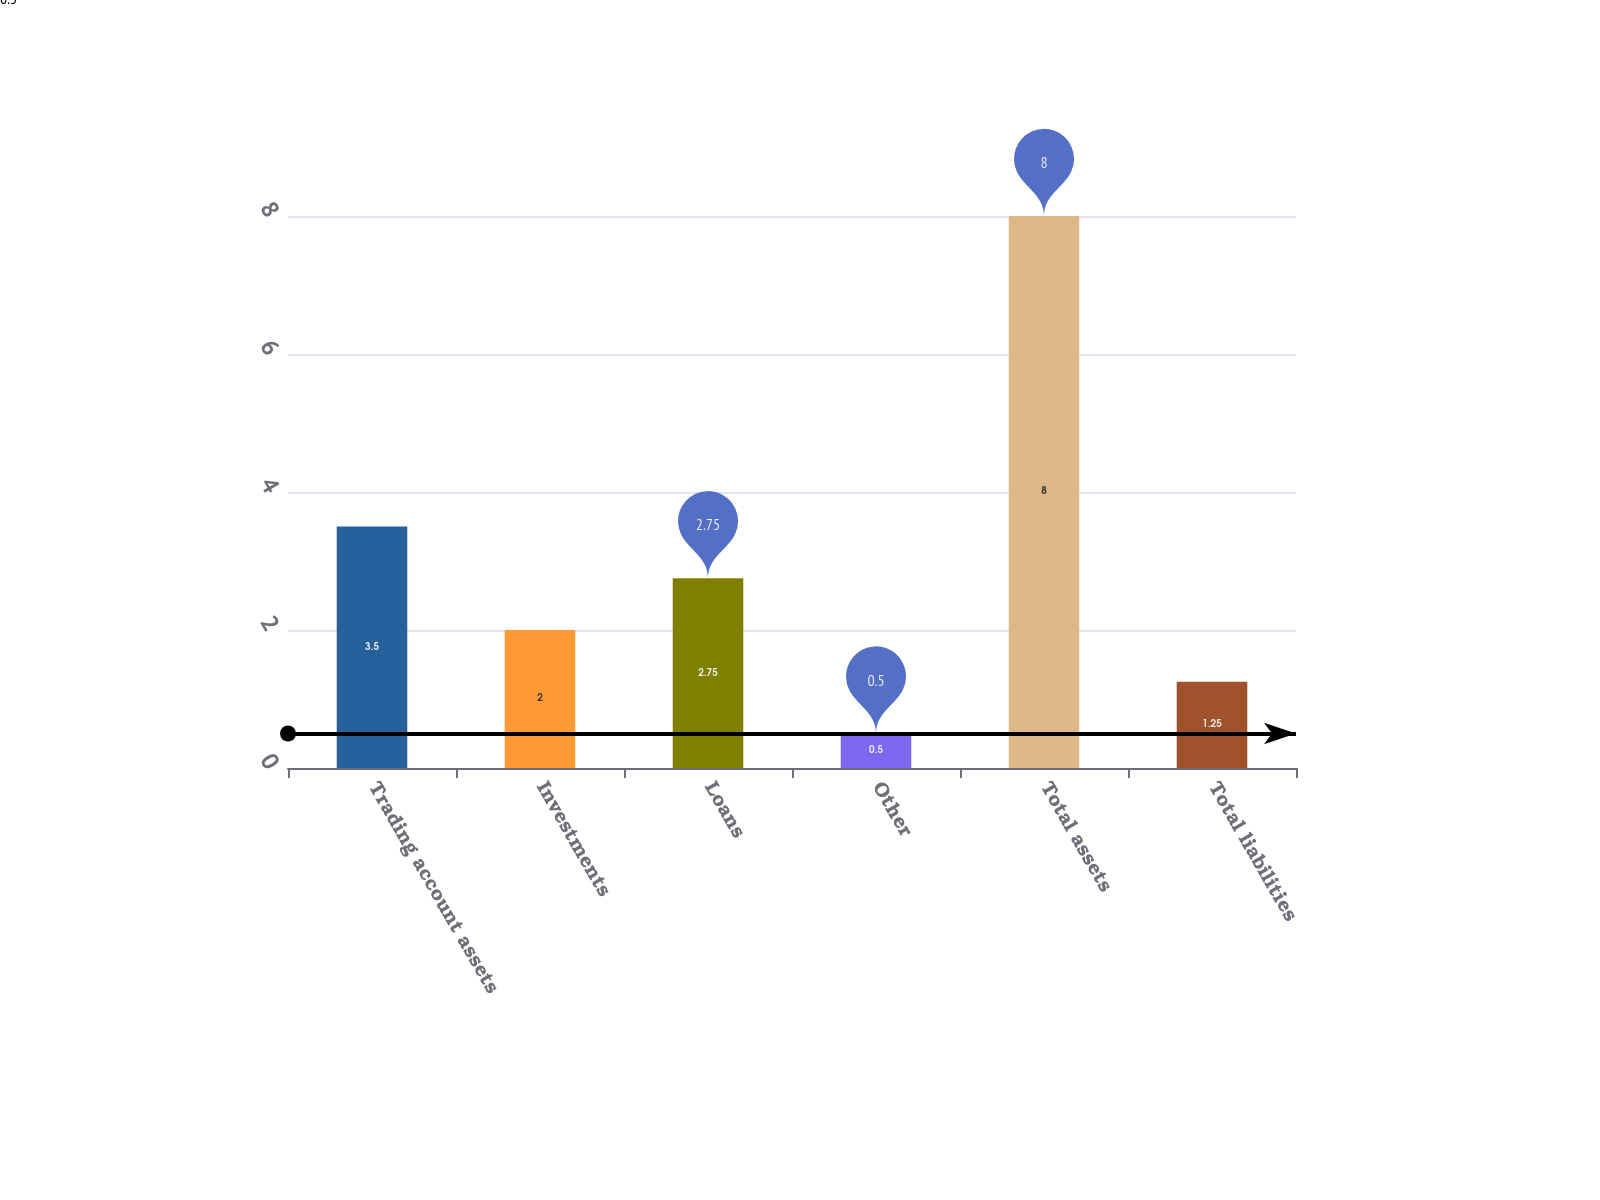<chart> <loc_0><loc_0><loc_500><loc_500><bar_chart><fcel>Trading account assets<fcel>Investments<fcel>Loans<fcel>Other<fcel>Total assets<fcel>Total liabilities<nl><fcel>3.5<fcel>2<fcel>2.75<fcel>0.5<fcel>8<fcel>1.25<nl></chart> 